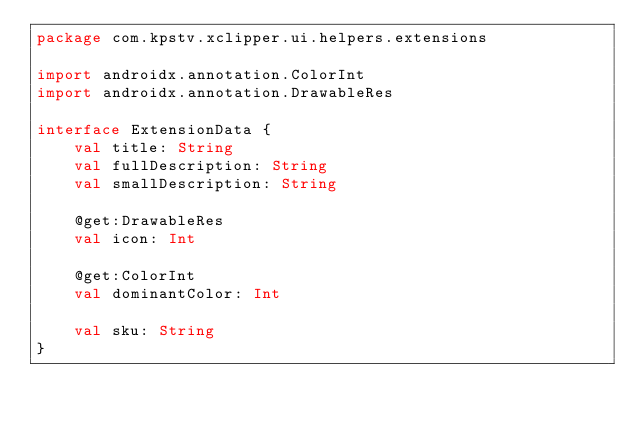<code> <loc_0><loc_0><loc_500><loc_500><_Kotlin_>package com.kpstv.xclipper.ui.helpers.extensions

import androidx.annotation.ColorInt
import androidx.annotation.DrawableRes

interface ExtensionData {
    val title: String
    val fullDescription: String
    val smallDescription: String

    @get:DrawableRes
    val icon: Int

    @get:ColorInt
    val dominantColor: Int

    val sku: String
}</code> 